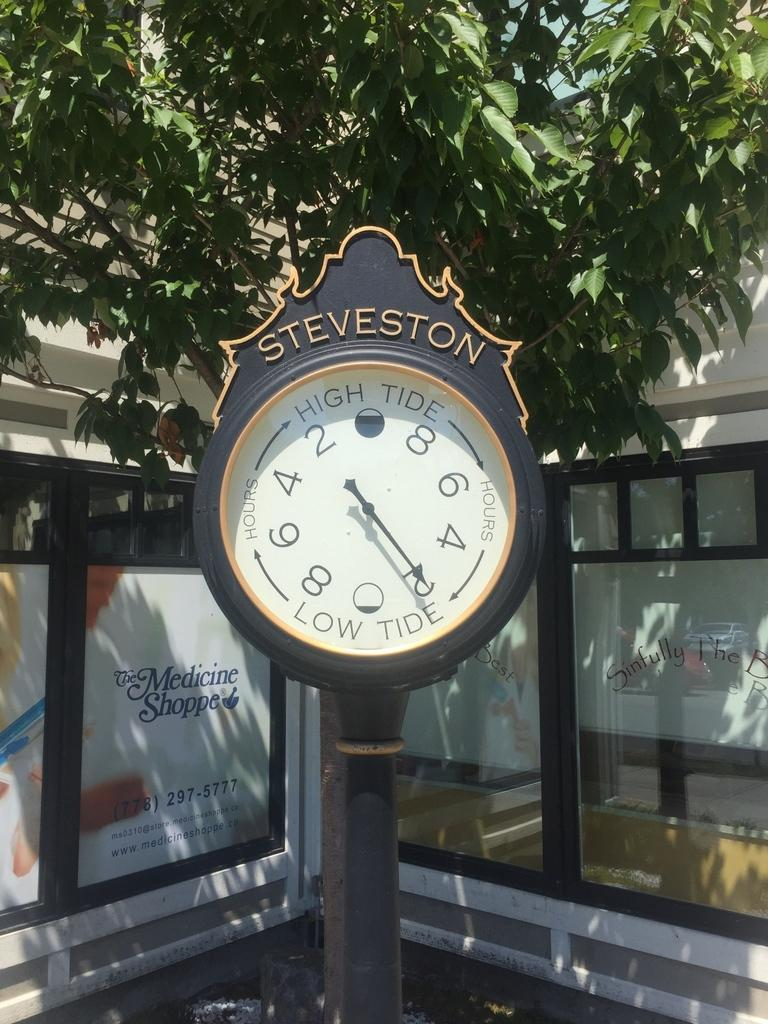Provide a one-sentence caption for the provided image. Low tide in Steveston will begin in two hours. 